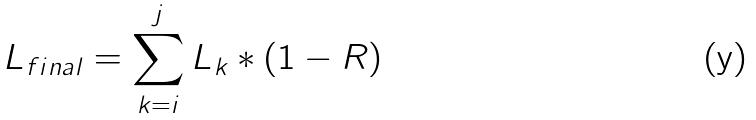Convert formula to latex. <formula><loc_0><loc_0><loc_500><loc_500>L _ { f i n a l } = \sum _ { k = i } ^ { j } L _ { k } * ( 1 - R )</formula> 